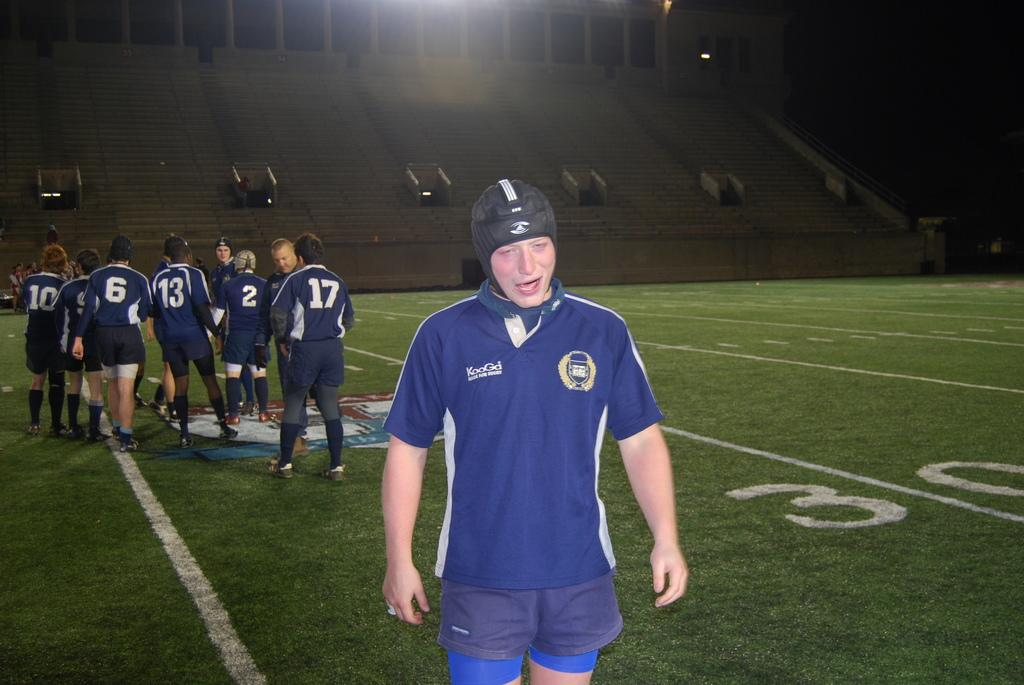<image>
Create a compact narrative representing the image presented. A soccer team is on a sports field and a player's shirt says KooGd. 